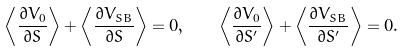<formula> <loc_0><loc_0><loc_500><loc_500>\left < \frac { \partial V _ { 0 } } { \partial S } \right > + \left < \frac { \partial V _ { S B } } { \partial S } \right > = 0 , \quad \left < \frac { \partial V _ { 0 } } { \partial S ^ { \prime } } \right > + \left < \frac { \partial V _ { S B } } { \partial S ^ { \prime } } \right > = 0 .</formula> 